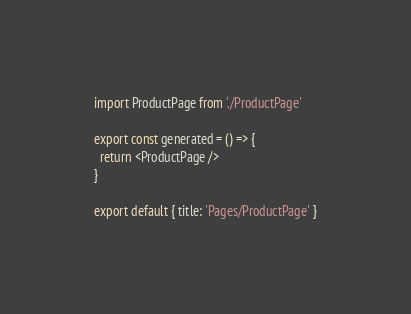<code> <loc_0><loc_0><loc_500><loc_500><_JavaScript_>import ProductPage from './ProductPage'

export const generated = () => {
  return <ProductPage />
}

export default { title: 'Pages/ProductPage' }
</code> 